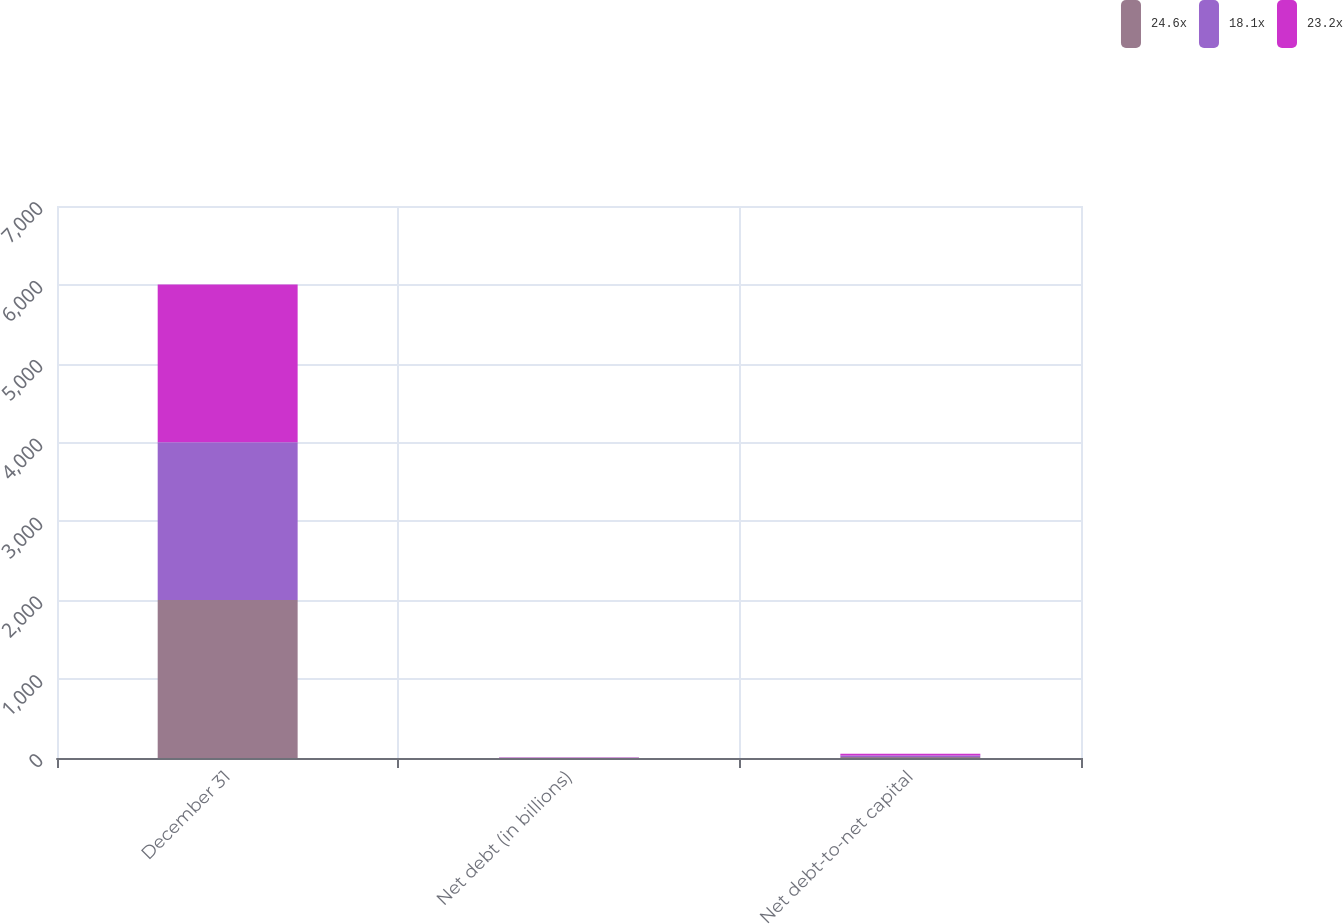Convert chart. <chart><loc_0><loc_0><loc_500><loc_500><stacked_bar_chart><ecel><fcel>December 31<fcel>Net debt (in billions)<fcel>Net debt-to-net capital<nl><fcel>24.6x<fcel>2003<fcel>1.9<fcel>12<nl><fcel>18.1x<fcel>2002<fcel>3<fcel>20<nl><fcel>23.2x<fcel>2001<fcel>3.2<fcel>22<nl></chart> 